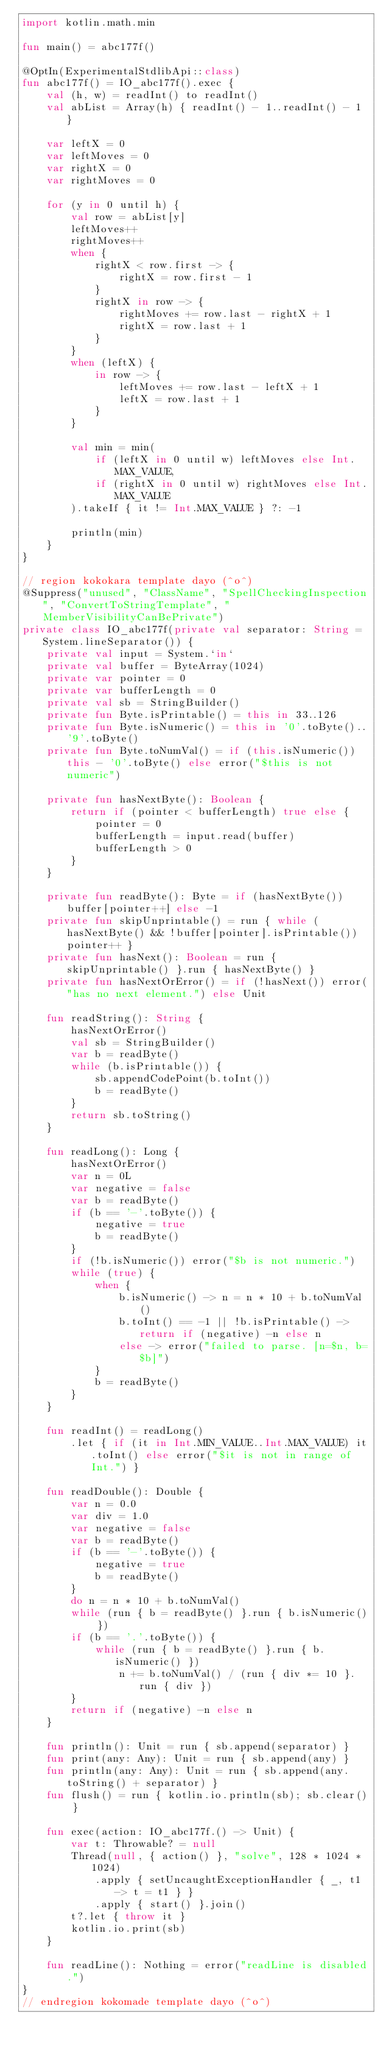<code> <loc_0><loc_0><loc_500><loc_500><_Kotlin_>import kotlin.math.min

fun main() = abc177f()

@OptIn(ExperimentalStdlibApi::class)
fun abc177f() = IO_abc177f().exec {
    val (h, w) = readInt() to readInt()
    val abList = Array(h) { readInt() - 1..readInt() - 1 }

    var leftX = 0
    var leftMoves = 0
    var rightX = 0
    var rightMoves = 0

    for (y in 0 until h) {
        val row = abList[y]
        leftMoves++
        rightMoves++
        when {
            rightX < row.first -> {
                rightX = row.first - 1
            }
            rightX in row -> {
                rightMoves += row.last - rightX + 1
                rightX = row.last + 1
            }
        }
        when (leftX) {
            in row -> {
                leftMoves += row.last - leftX + 1
                leftX = row.last + 1
            }
        }

        val min = min(
            if (leftX in 0 until w) leftMoves else Int.MAX_VALUE,
            if (rightX in 0 until w) rightMoves else Int.MAX_VALUE
        ).takeIf { it != Int.MAX_VALUE } ?: -1

        println(min)
    }
}

// region kokokara template dayo (^o^)
@Suppress("unused", "ClassName", "SpellCheckingInspection", "ConvertToStringTemplate", "MemberVisibilityCanBePrivate")
private class IO_abc177f(private val separator: String = System.lineSeparator()) {
    private val input = System.`in`
    private val buffer = ByteArray(1024)
    private var pointer = 0
    private var bufferLength = 0
    private val sb = StringBuilder()
    private fun Byte.isPrintable() = this in 33..126
    private fun Byte.isNumeric() = this in '0'.toByte()..'9'.toByte()
    private fun Byte.toNumVal() = if (this.isNumeric()) this - '0'.toByte() else error("$this is not numeric")

    private fun hasNextByte(): Boolean {
        return if (pointer < bufferLength) true else {
            pointer = 0
            bufferLength = input.read(buffer)
            bufferLength > 0
        }
    }

    private fun readByte(): Byte = if (hasNextByte()) buffer[pointer++] else -1
    private fun skipUnprintable() = run { while (hasNextByte() && !buffer[pointer].isPrintable()) pointer++ }
    private fun hasNext(): Boolean = run { skipUnprintable() }.run { hasNextByte() }
    private fun hasNextOrError() = if (!hasNext()) error("has no next element.") else Unit

    fun readString(): String {
        hasNextOrError()
        val sb = StringBuilder()
        var b = readByte()
        while (b.isPrintable()) {
            sb.appendCodePoint(b.toInt())
            b = readByte()
        }
        return sb.toString()
    }

    fun readLong(): Long {
        hasNextOrError()
        var n = 0L
        var negative = false
        var b = readByte()
        if (b == '-'.toByte()) {
            negative = true
            b = readByte()
        }
        if (!b.isNumeric()) error("$b is not numeric.")
        while (true) {
            when {
                b.isNumeric() -> n = n * 10 + b.toNumVal()
                b.toInt() == -1 || !b.isPrintable() -> return if (negative) -n else n
                else -> error("failed to parse. [n=$n, b=$b]")
            }
            b = readByte()
        }
    }

    fun readInt() = readLong()
        .let { if (it in Int.MIN_VALUE..Int.MAX_VALUE) it.toInt() else error("$it is not in range of Int.") }

    fun readDouble(): Double {
        var n = 0.0
        var div = 1.0
        var negative = false
        var b = readByte()
        if (b == '-'.toByte()) {
            negative = true
            b = readByte()
        }
        do n = n * 10 + b.toNumVal()
        while (run { b = readByte() }.run { b.isNumeric() })
        if (b == '.'.toByte()) {
            while (run { b = readByte() }.run { b.isNumeric() })
                n += b.toNumVal() / (run { div *= 10 }.run { div })
        }
        return if (negative) -n else n
    }

    fun println(): Unit = run { sb.append(separator) }
    fun print(any: Any): Unit = run { sb.append(any) }
    fun println(any: Any): Unit = run { sb.append(any.toString() + separator) }
    fun flush() = run { kotlin.io.println(sb); sb.clear() }

    fun exec(action: IO_abc177f.() -> Unit) {
        var t: Throwable? = null
        Thread(null, { action() }, "solve", 128 * 1024 * 1024)
            .apply { setUncaughtExceptionHandler { _, t1 -> t = t1 } }
            .apply { start() }.join()
        t?.let { throw it }
        kotlin.io.print(sb)
    }

    fun readLine(): Nothing = error("readLine is disabled.")
}
// endregion kokomade template dayo (^o^)
</code> 